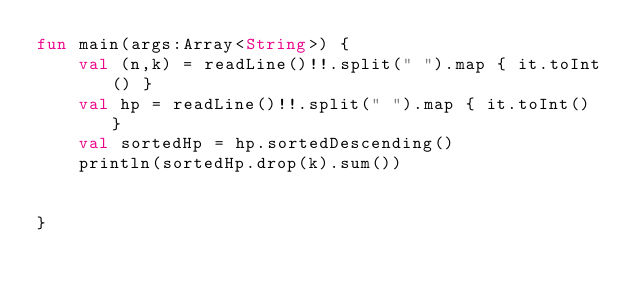Convert code to text. <code><loc_0><loc_0><loc_500><loc_500><_Kotlin_>fun main(args:Array<String>) {
    val (n,k) = readLine()!!.split(" ").map { it.toInt() }
    val hp = readLine()!!.split(" ").map { it.toInt() }
    val sortedHp = hp.sortedDescending()
    println(sortedHp.drop(k).sum())


}</code> 